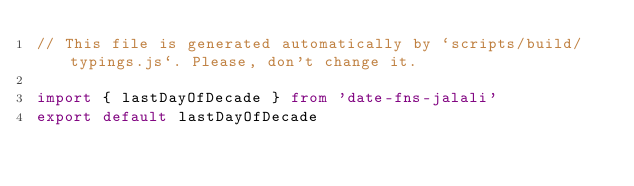<code> <loc_0><loc_0><loc_500><loc_500><_TypeScript_>// This file is generated automatically by `scripts/build/typings.js`. Please, don't change it.

import { lastDayOfDecade } from 'date-fns-jalali'
export default lastDayOfDecade
</code> 